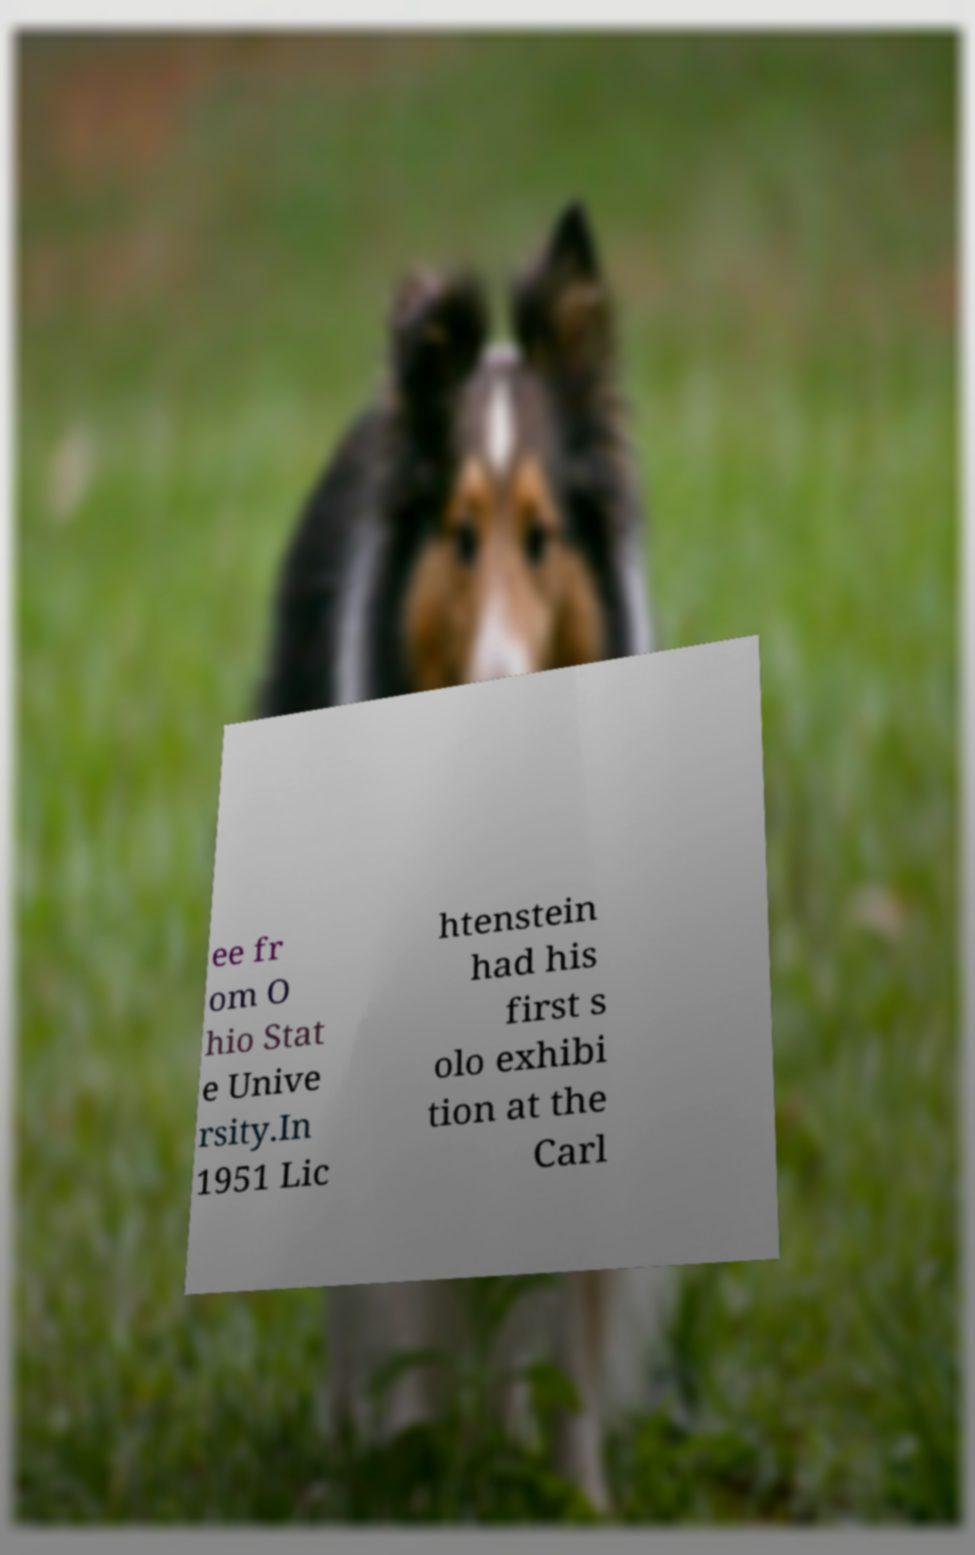Please read and relay the text visible in this image. What does it say? ee fr om O hio Stat e Unive rsity.In 1951 Lic htenstein had his first s olo exhibi tion at the Carl 